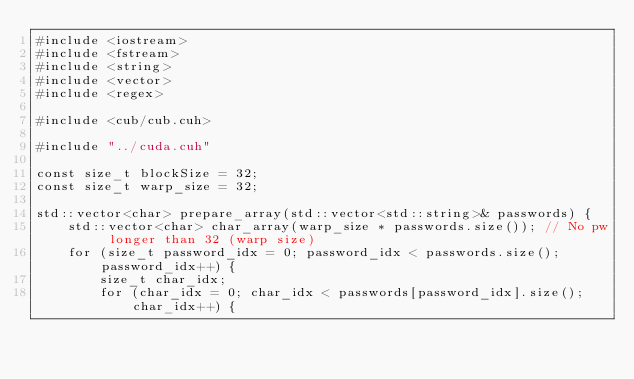<code> <loc_0><loc_0><loc_500><loc_500><_Cuda_>#include <iostream>
#include <fstream>
#include <string>
#include <vector>
#include <regex>

#include <cub/cub.cuh>

#include "../cuda.cuh"

const size_t blockSize = 32;
const size_t warp_size = 32;

std::vector<char> prepare_array(std::vector<std::string>& passwords) {
    std::vector<char> char_array(warp_size * passwords.size()); // No pw longer than 32 (warp size)
    for (size_t password_idx = 0; password_idx < passwords.size(); password_idx++) {
        size_t char_idx;
        for (char_idx = 0; char_idx < passwords[password_idx].size(); char_idx++) {</code> 